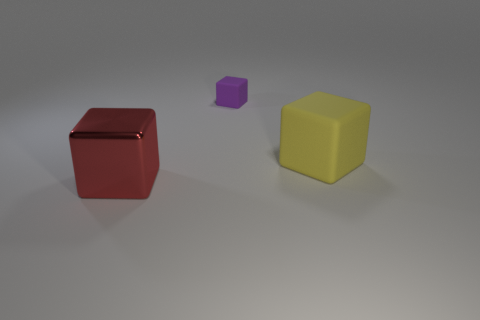Are there any other things that have the same size as the purple matte cube?
Give a very brief answer. No. Is the number of large rubber things that are on the left side of the large red block the same as the number of purple rubber cubes that are behind the big rubber thing?
Offer a very short reply. No. Is there anything else that is made of the same material as the big red thing?
Offer a very short reply. No. There is a purple rubber object; is it the same size as the block that is to the left of the small purple matte block?
Ensure brevity in your answer.  No. How many other things are there of the same color as the small matte thing?
Offer a very short reply. 0. There is a purple rubber thing; are there any blocks to the left of it?
Offer a very short reply. Yes. How many things are either small objects or cubes that are behind the red block?
Your answer should be very brief. 2. There is a thing to the left of the small purple rubber object; is there a matte object to the right of it?
Make the answer very short. Yes. What shape is the rubber object that is behind the matte object that is to the right of the object that is behind the yellow matte object?
Your answer should be compact. Cube. What color is the block that is both left of the yellow matte thing and in front of the small purple thing?
Your answer should be compact. Red. 